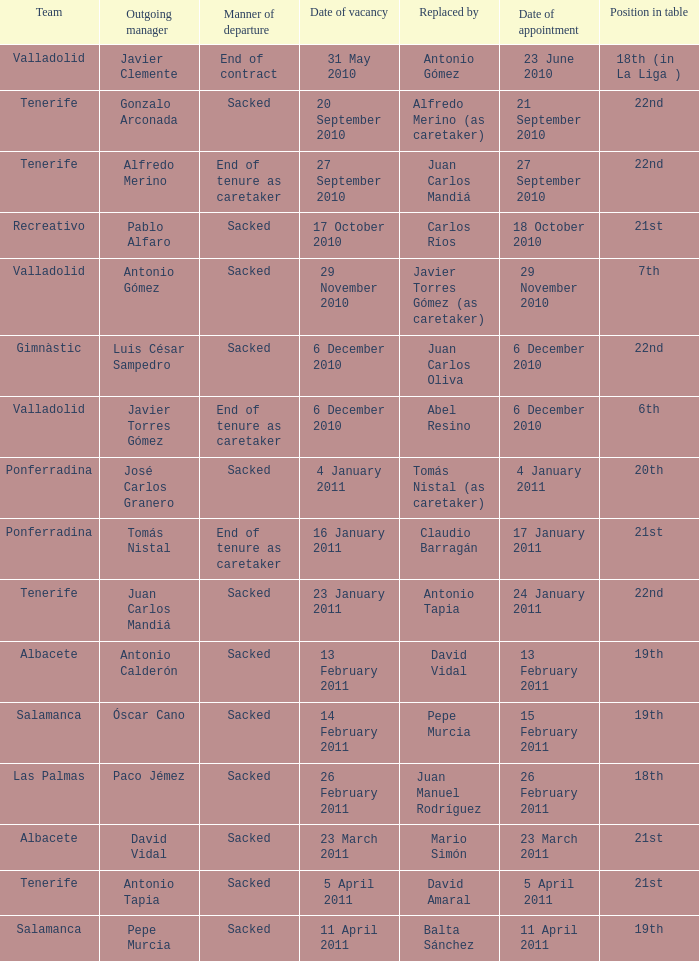How many teams had an outgoing manager of antonio gómez 1.0. 